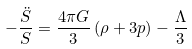Convert formula to latex. <formula><loc_0><loc_0><loc_500><loc_500>- \frac { \ddot { S } } { S } = \frac { 4 \pi G } { 3 } \left ( \rho + 3 p \right ) - \frac { \Lambda } { 3 }</formula> 